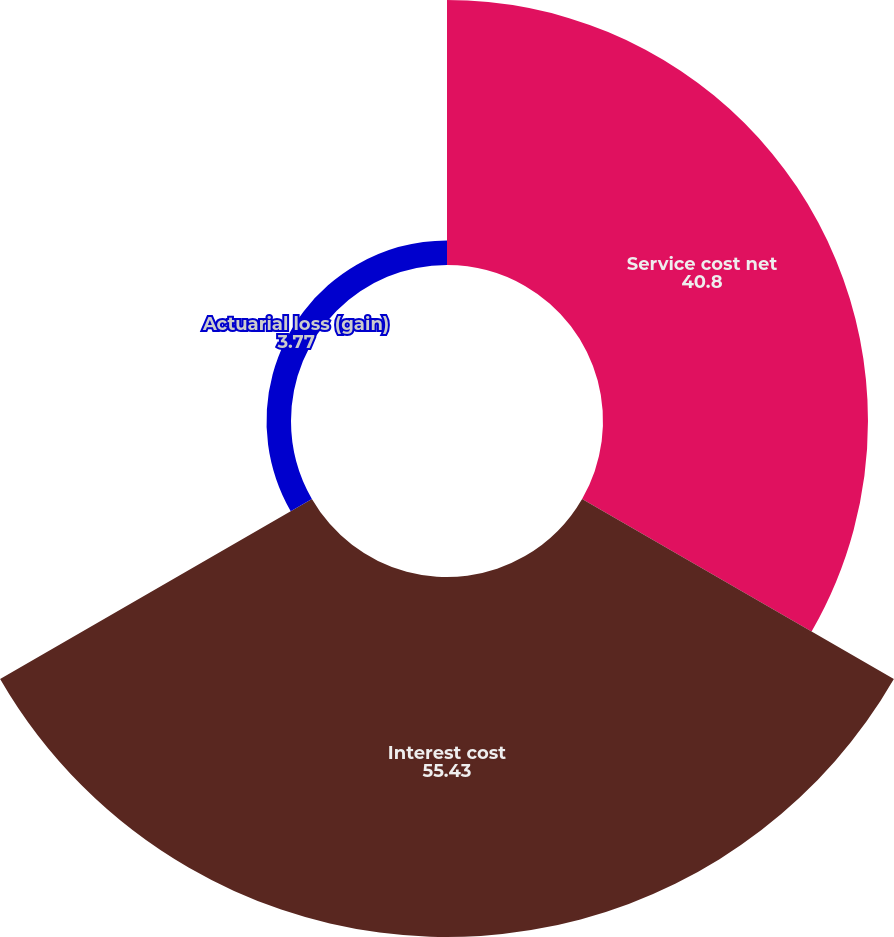Convert chart. <chart><loc_0><loc_0><loc_500><loc_500><pie_chart><fcel>Service cost net<fcel>Interest cost<fcel>Actuarial loss (gain)<nl><fcel>40.8%<fcel>55.43%<fcel>3.77%<nl></chart> 